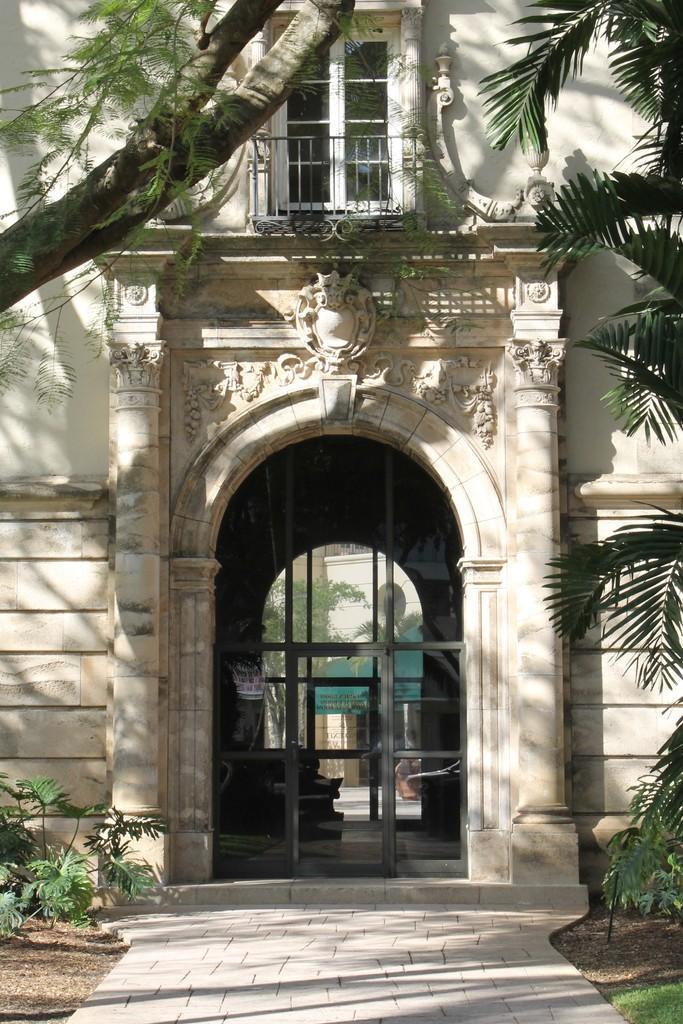Describe this image in one or two sentences. In-front of this building there are plants and tree. Here we can see window and glass door. 